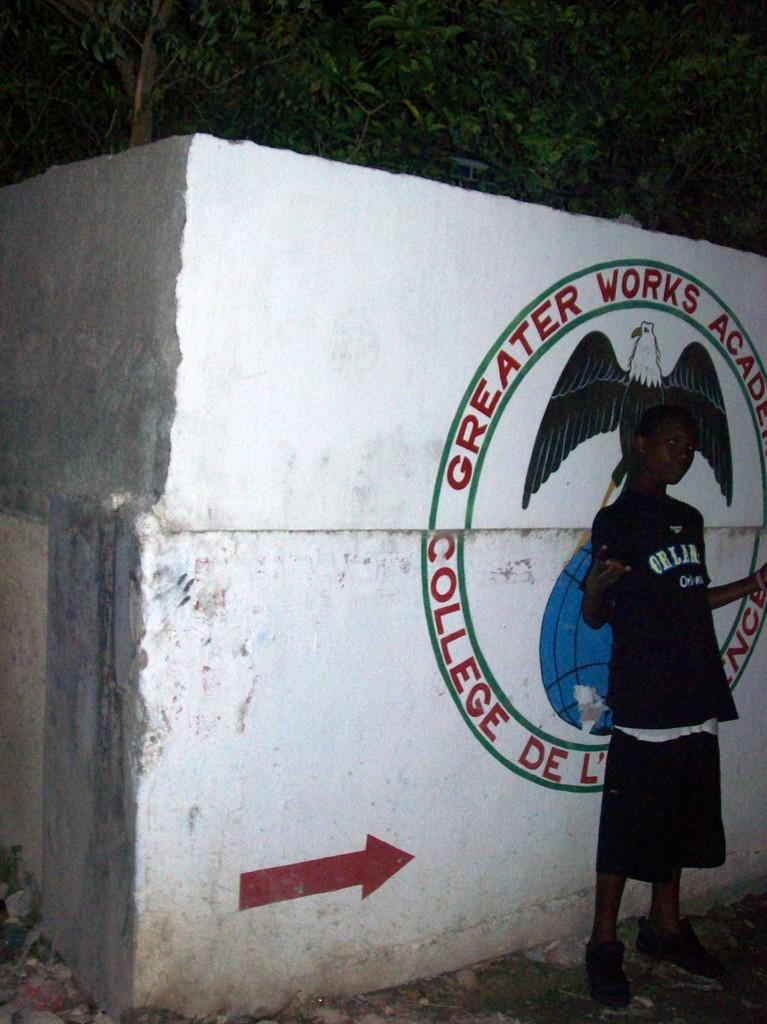<image>
Present a compact description of the photo's key features. a boy stands in front of a concrete wall with Greater Works on it 